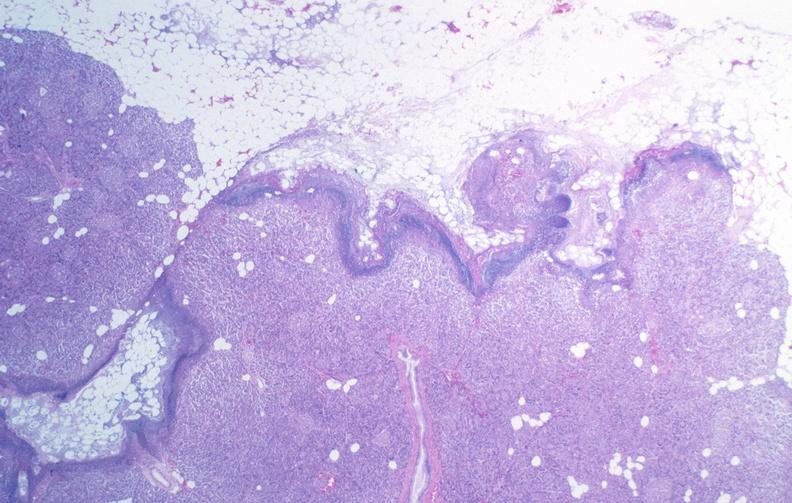does adrenal of premature 30 week gestation gram infant lesion show pancreatic fat necrosis?
Answer the question using a single word or phrase. No 